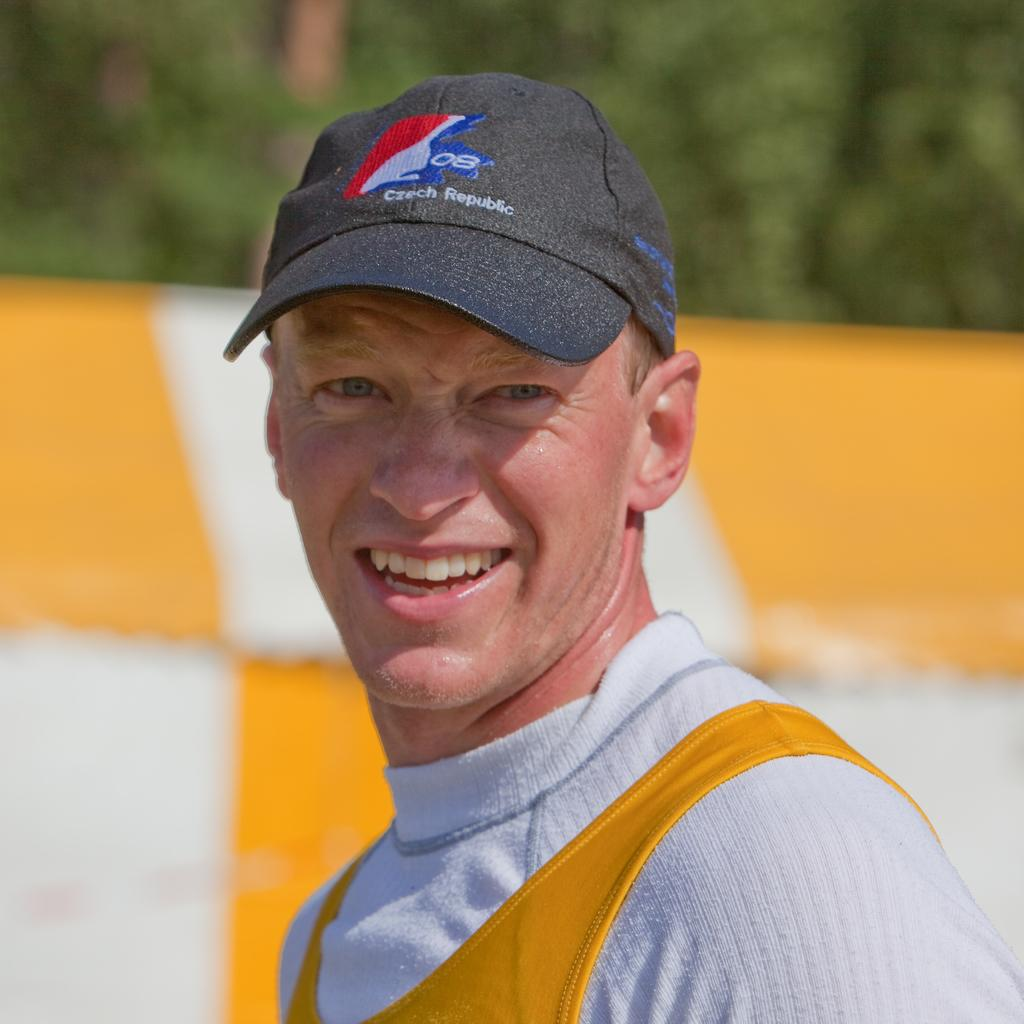<image>
Share a concise interpretation of the image provided. Man wearing a black cap which says "Czech Republic " on it. 